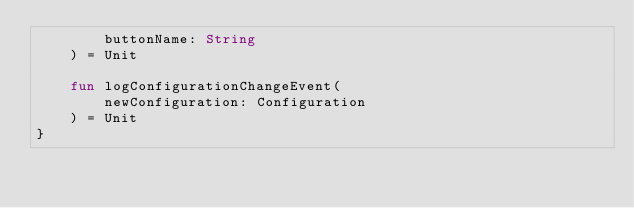Convert code to text. <code><loc_0><loc_0><loc_500><loc_500><_Kotlin_>        buttonName: String
    ) = Unit

    fun logConfigurationChangeEvent(
        newConfiguration: Configuration
    ) = Unit
}</code> 